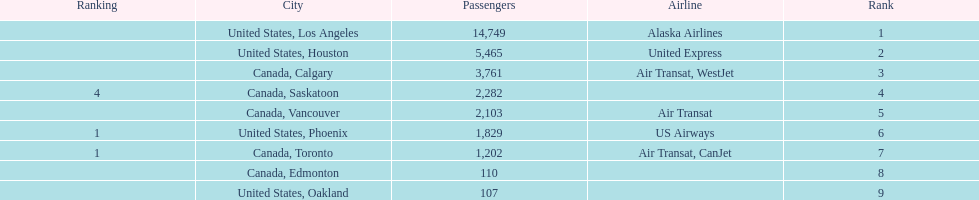In 2013, was the busiest international route at manzanillo international airport from los angeles or houston? Los Angeles. 